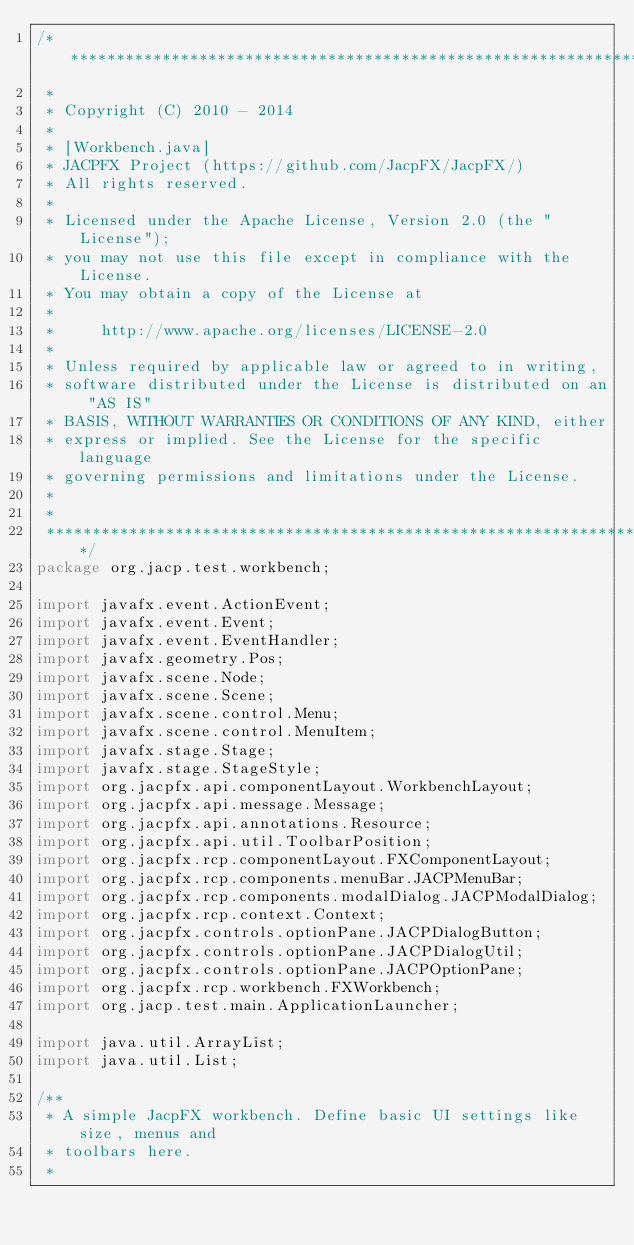Convert code to text. <code><loc_0><loc_0><loc_500><loc_500><_Java_>/************************************************************************
 *
 * Copyright (C) 2010 - 2014
 *
 * [Workbench.java]
 * JACPFX Project (https://github.com/JacpFX/JacpFX/)
 * All rights reserved.
 *
 * Licensed under the Apache License, Version 2.0 (the "License");
 * you may not use this file except in compliance with the License.
 * You may obtain a copy of the License at 
 *
 *     http://www.apache.org/licenses/LICENSE-2.0 
 *
 * Unless required by applicable law or agreed to in writing,
 * software distributed under the License is distributed on an "AS IS"
 * BASIS, WITHOUT WARRANTIES OR CONDITIONS OF ANY KIND, either 
 * express or implied. See the License for the specific language
 * governing permissions and limitations under the License.
 *
 *
 ************************************************************************/
package org.jacp.test.workbench;

import javafx.event.ActionEvent;
import javafx.event.Event;
import javafx.event.EventHandler;
import javafx.geometry.Pos;
import javafx.scene.Node;
import javafx.scene.Scene;
import javafx.scene.control.Menu;
import javafx.scene.control.MenuItem;
import javafx.stage.Stage;
import javafx.stage.StageStyle;
import org.jacpfx.api.componentLayout.WorkbenchLayout;
import org.jacpfx.api.message.Message;
import org.jacpfx.api.annotations.Resource;
import org.jacpfx.api.util.ToolbarPosition;
import org.jacpfx.rcp.componentLayout.FXComponentLayout;
import org.jacpfx.rcp.components.menuBar.JACPMenuBar;
import org.jacpfx.rcp.components.modalDialog.JACPModalDialog;
import org.jacpfx.rcp.context.Context;
import org.jacpfx.controls.optionPane.JACPDialogButton;
import org.jacpfx.controls.optionPane.JACPDialogUtil;
import org.jacpfx.controls.optionPane.JACPOptionPane;
import org.jacpfx.rcp.workbench.FXWorkbench;
import org.jacp.test.main.ApplicationLauncher;

import java.util.ArrayList;
import java.util.List;

/**
 * A simple JacpFX workbench. Define basic UI settings like size, menus and
 * toolbars here.
 *</code> 